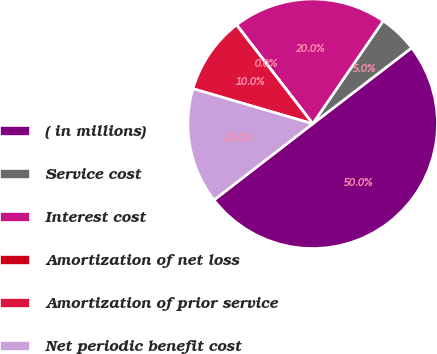<chart> <loc_0><loc_0><loc_500><loc_500><pie_chart><fcel>( in millions)<fcel>Service cost<fcel>Interest cost<fcel>Amortization of net loss<fcel>Amortization of prior service<fcel>Net periodic benefit cost<nl><fcel>49.95%<fcel>5.02%<fcel>20.0%<fcel>0.02%<fcel>10.01%<fcel>15.0%<nl></chart> 